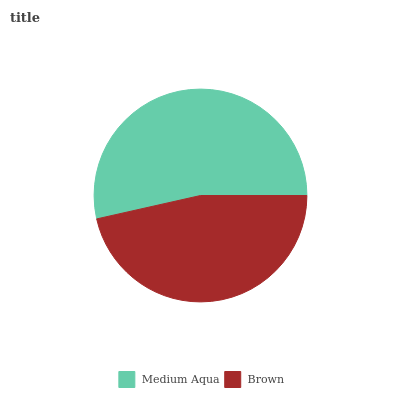Is Brown the minimum?
Answer yes or no. Yes. Is Medium Aqua the maximum?
Answer yes or no. Yes. Is Brown the maximum?
Answer yes or no. No. Is Medium Aqua greater than Brown?
Answer yes or no. Yes. Is Brown less than Medium Aqua?
Answer yes or no. Yes. Is Brown greater than Medium Aqua?
Answer yes or no. No. Is Medium Aqua less than Brown?
Answer yes or no. No. Is Medium Aqua the high median?
Answer yes or no. Yes. Is Brown the low median?
Answer yes or no. Yes. Is Brown the high median?
Answer yes or no. No. Is Medium Aqua the low median?
Answer yes or no. No. 